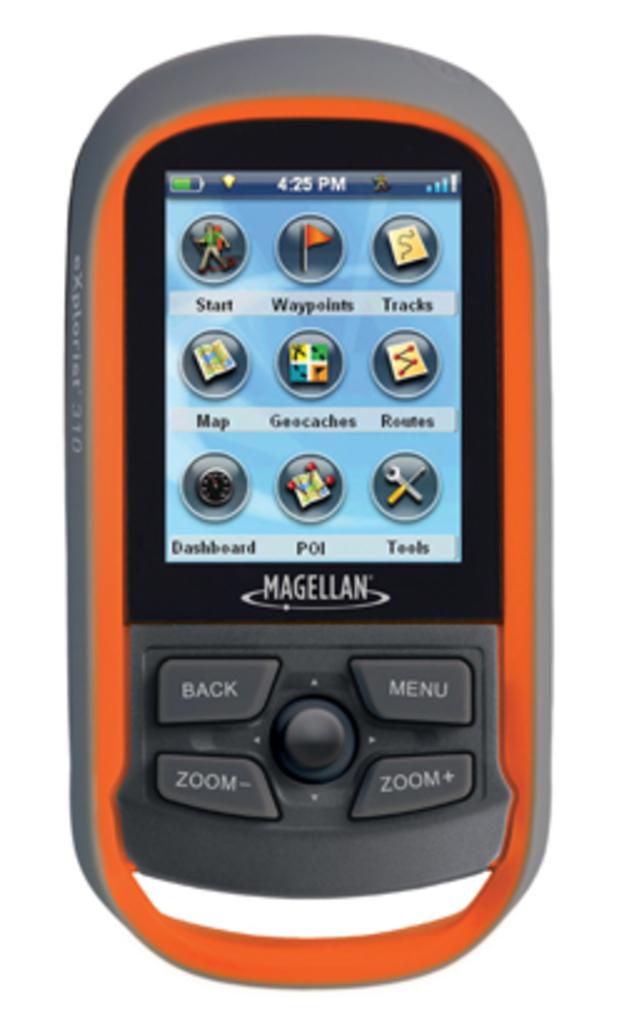<image>
Provide a brief description of the given image. A Magellan phone with the time of 4:25 P.M. on the display screen. 